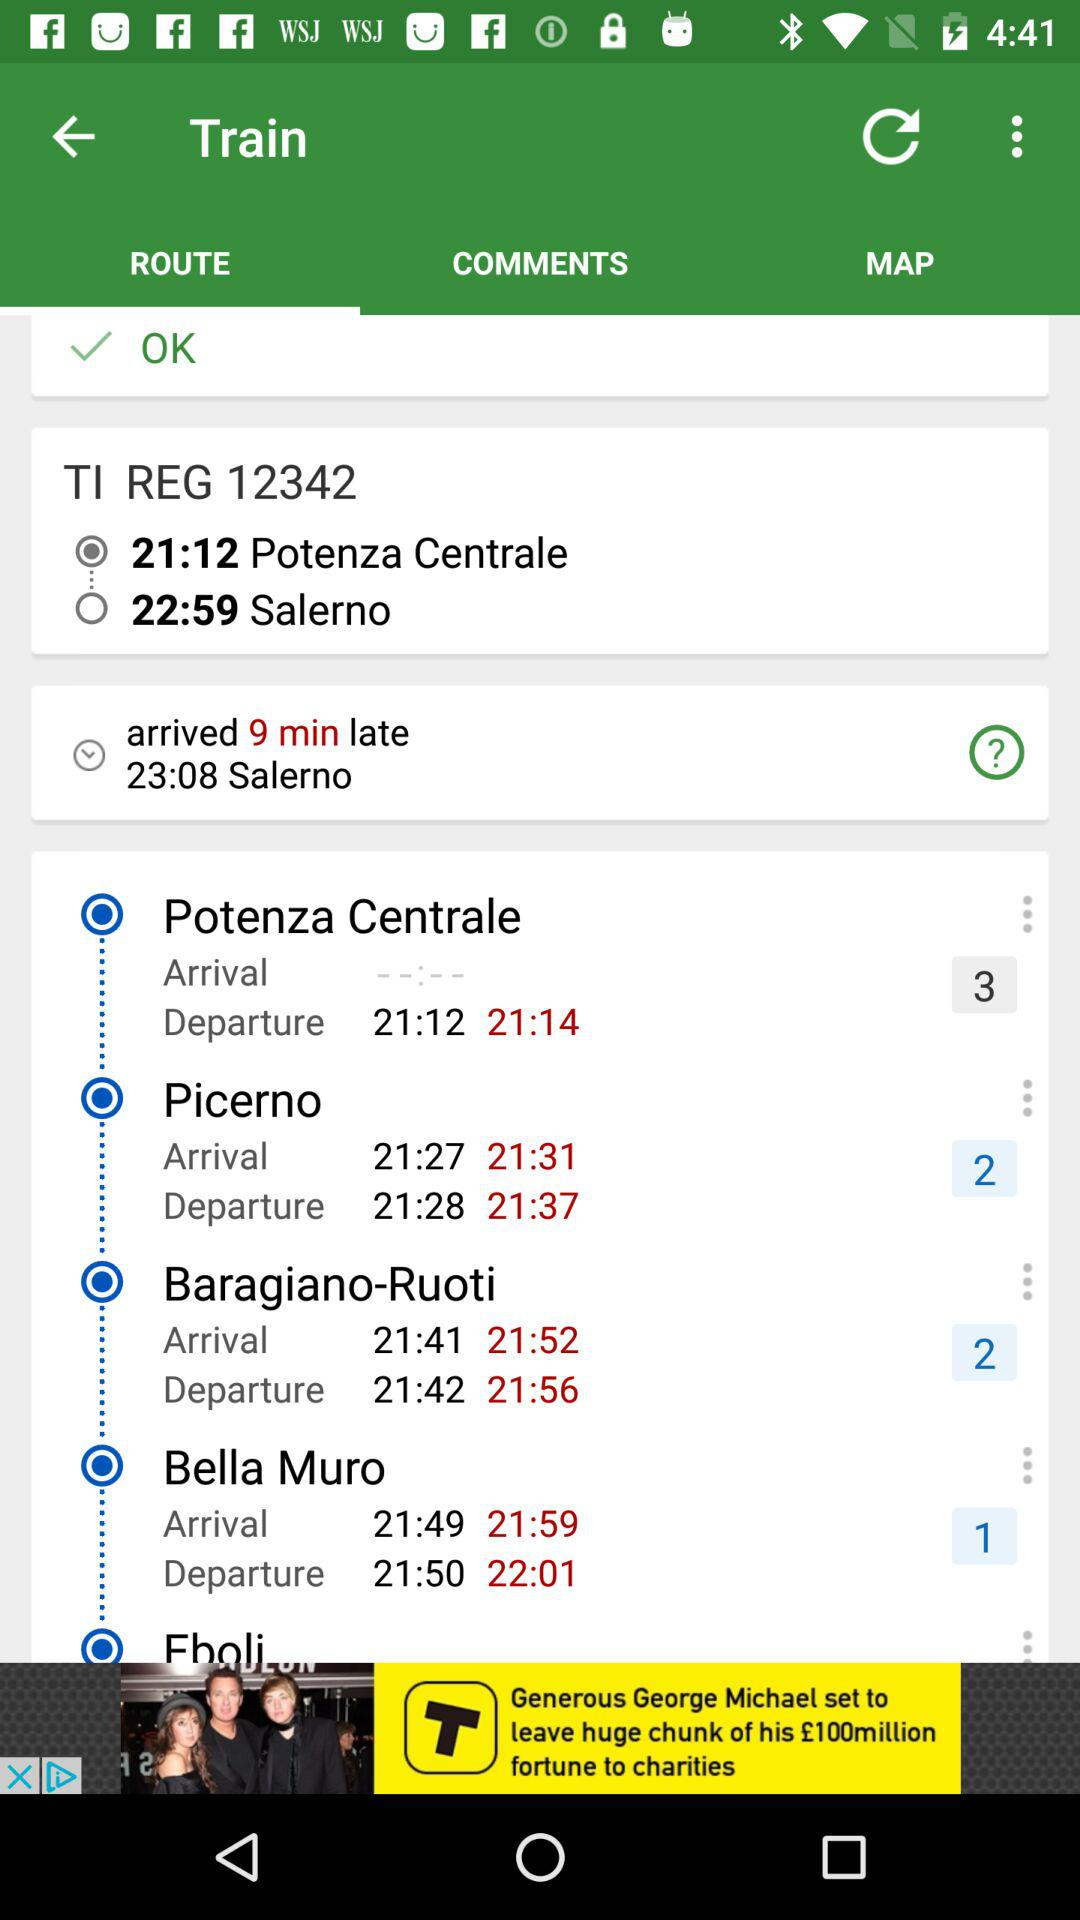What is the start location? The start location is "Potenza Centrale". 